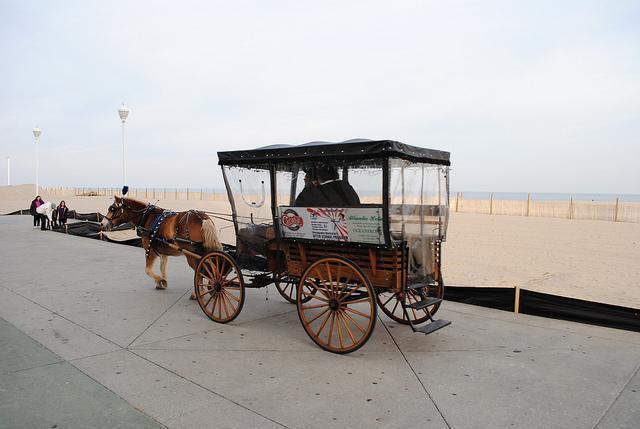How many wheels do these items have?
Give a very brief answer. 4. How many horses are pulling the cart?
Give a very brief answer. 1. How many wheels is on the carriage?
Give a very brief answer. 4. How many horses are in the photo?
Give a very brief answer. 1. How many legs is the cat standing on?
Give a very brief answer. 0. 